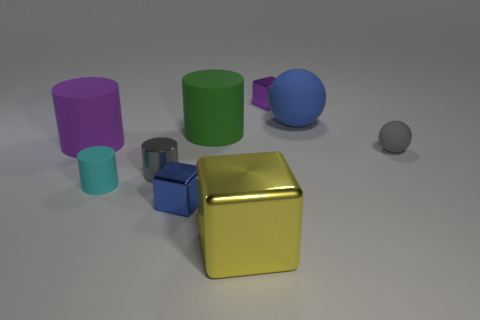What number of other things are the same color as the big metal cube? Upon review, I see one item that shares the same color as the large golden cube - it's a small cube right next to it. 